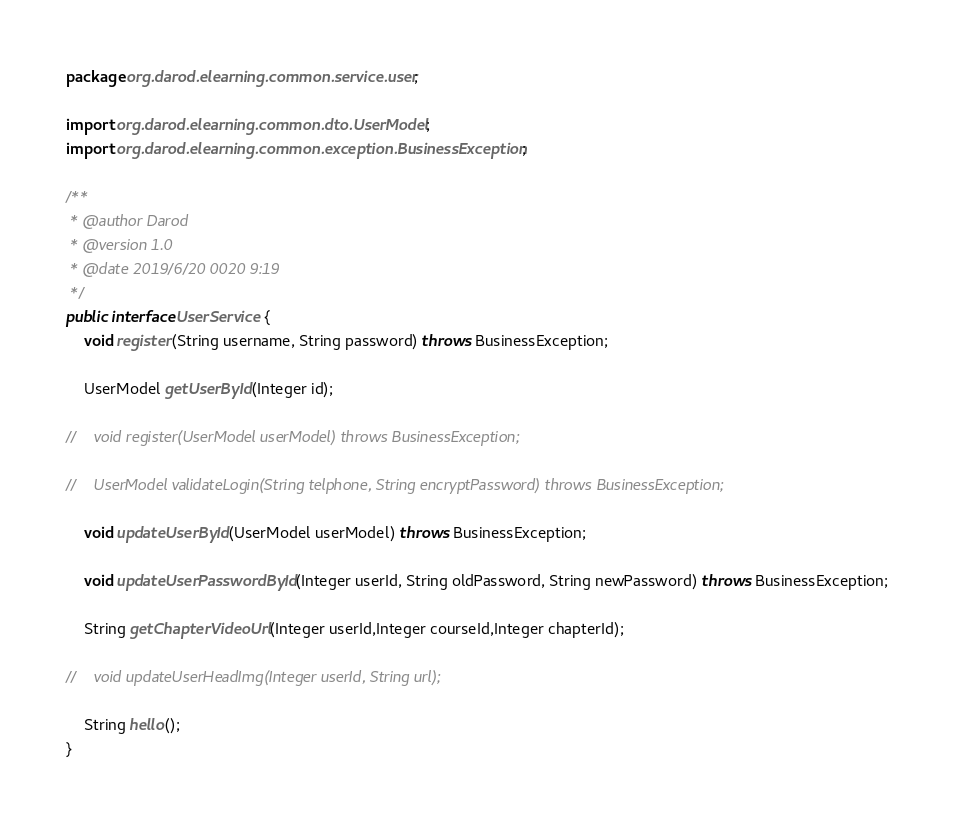<code> <loc_0><loc_0><loc_500><loc_500><_Java_>package org.darod.elearning.common.service.user;

import org.darod.elearning.common.dto.UserModel;
import org.darod.elearning.common.exception.BusinessException;

/**
 * @author Darod
 * @version 1.0
 * @date 2019/6/20 0020 9:19
 */
public interface UserService {
    void register(String username, String password) throws BusinessException;

    UserModel getUserById(Integer id);

//    void register(UserModel userModel) throws BusinessException;

//    UserModel validateLogin(String telphone, String encryptPassword) throws BusinessException;

    void updateUserById(UserModel userModel) throws BusinessException;

    void updateUserPasswordById(Integer userId, String oldPassword, String newPassword) throws BusinessException;

    String getChapterVideoUrl(Integer userId,Integer courseId,Integer chapterId);

//    void updateUserHeadImg(Integer userId, String url);

    String hello();
}
</code> 